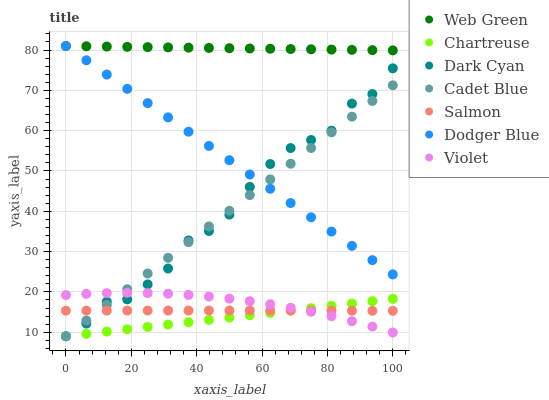Does Chartreuse have the minimum area under the curve?
Answer yes or no. Yes. Does Web Green have the maximum area under the curve?
Answer yes or no. Yes. Does Salmon have the minimum area under the curve?
Answer yes or no. No. Does Salmon have the maximum area under the curve?
Answer yes or no. No. Is Chartreuse the smoothest?
Answer yes or no. Yes. Is Dark Cyan the roughest?
Answer yes or no. Yes. Is Salmon the smoothest?
Answer yes or no. No. Is Salmon the roughest?
Answer yes or no. No. Does Cadet Blue have the lowest value?
Answer yes or no. Yes. Does Salmon have the lowest value?
Answer yes or no. No. Does Dodger Blue have the highest value?
Answer yes or no. Yes. Does Salmon have the highest value?
Answer yes or no. No. Is Cadet Blue less than Web Green?
Answer yes or no. Yes. Is Web Green greater than Chartreuse?
Answer yes or no. Yes. Does Violet intersect Chartreuse?
Answer yes or no. Yes. Is Violet less than Chartreuse?
Answer yes or no. No. Is Violet greater than Chartreuse?
Answer yes or no. No. Does Cadet Blue intersect Web Green?
Answer yes or no. No. 